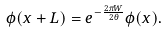Convert formula to latex. <formula><loc_0><loc_0><loc_500><loc_500>\phi ( x + L ) = e ^ { - \frac { 2 \pi W } { 2 \theta } } \phi ( x ) .</formula> 